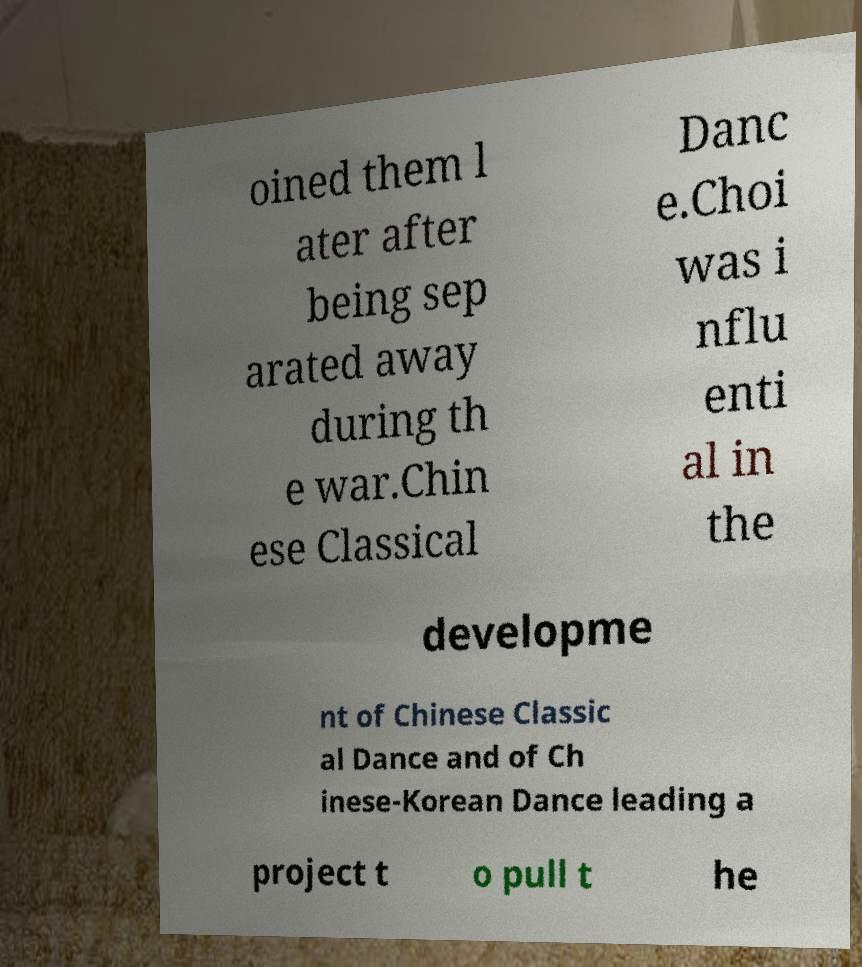Could you extract and type out the text from this image? oined them l ater after being sep arated away during th e war.Chin ese Classical Danc e.Choi was i nflu enti al in the developme nt of Chinese Classic al Dance and of Ch inese-Korean Dance leading a project t o pull t he 